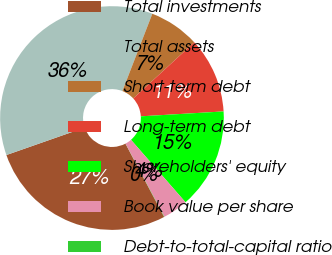<chart> <loc_0><loc_0><loc_500><loc_500><pie_chart><fcel>Total investments<fcel>Total assets<fcel>Short-term debt<fcel>Long-term debt<fcel>Shareholders' equity<fcel>Book value per share<fcel>Debt-to-total-capital ratio<nl><fcel>27.36%<fcel>36.25%<fcel>7.28%<fcel>10.9%<fcel>14.52%<fcel>3.66%<fcel>0.04%<nl></chart> 